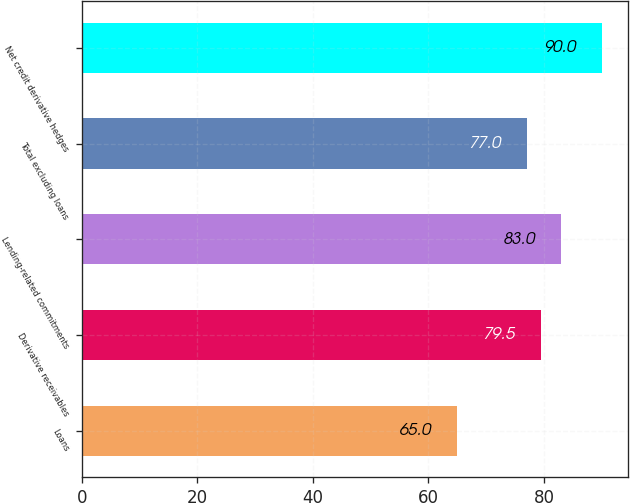Convert chart. <chart><loc_0><loc_0><loc_500><loc_500><bar_chart><fcel>Loans<fcel>Derivative receivables<fcel>Lending-related commitments<fcel>Total excluding loans<fcel>Net credit derivative hedges<nl><fcel>65<fcel>79.5<fcel>83<fcel>77<fcel>90<nl></chart> 